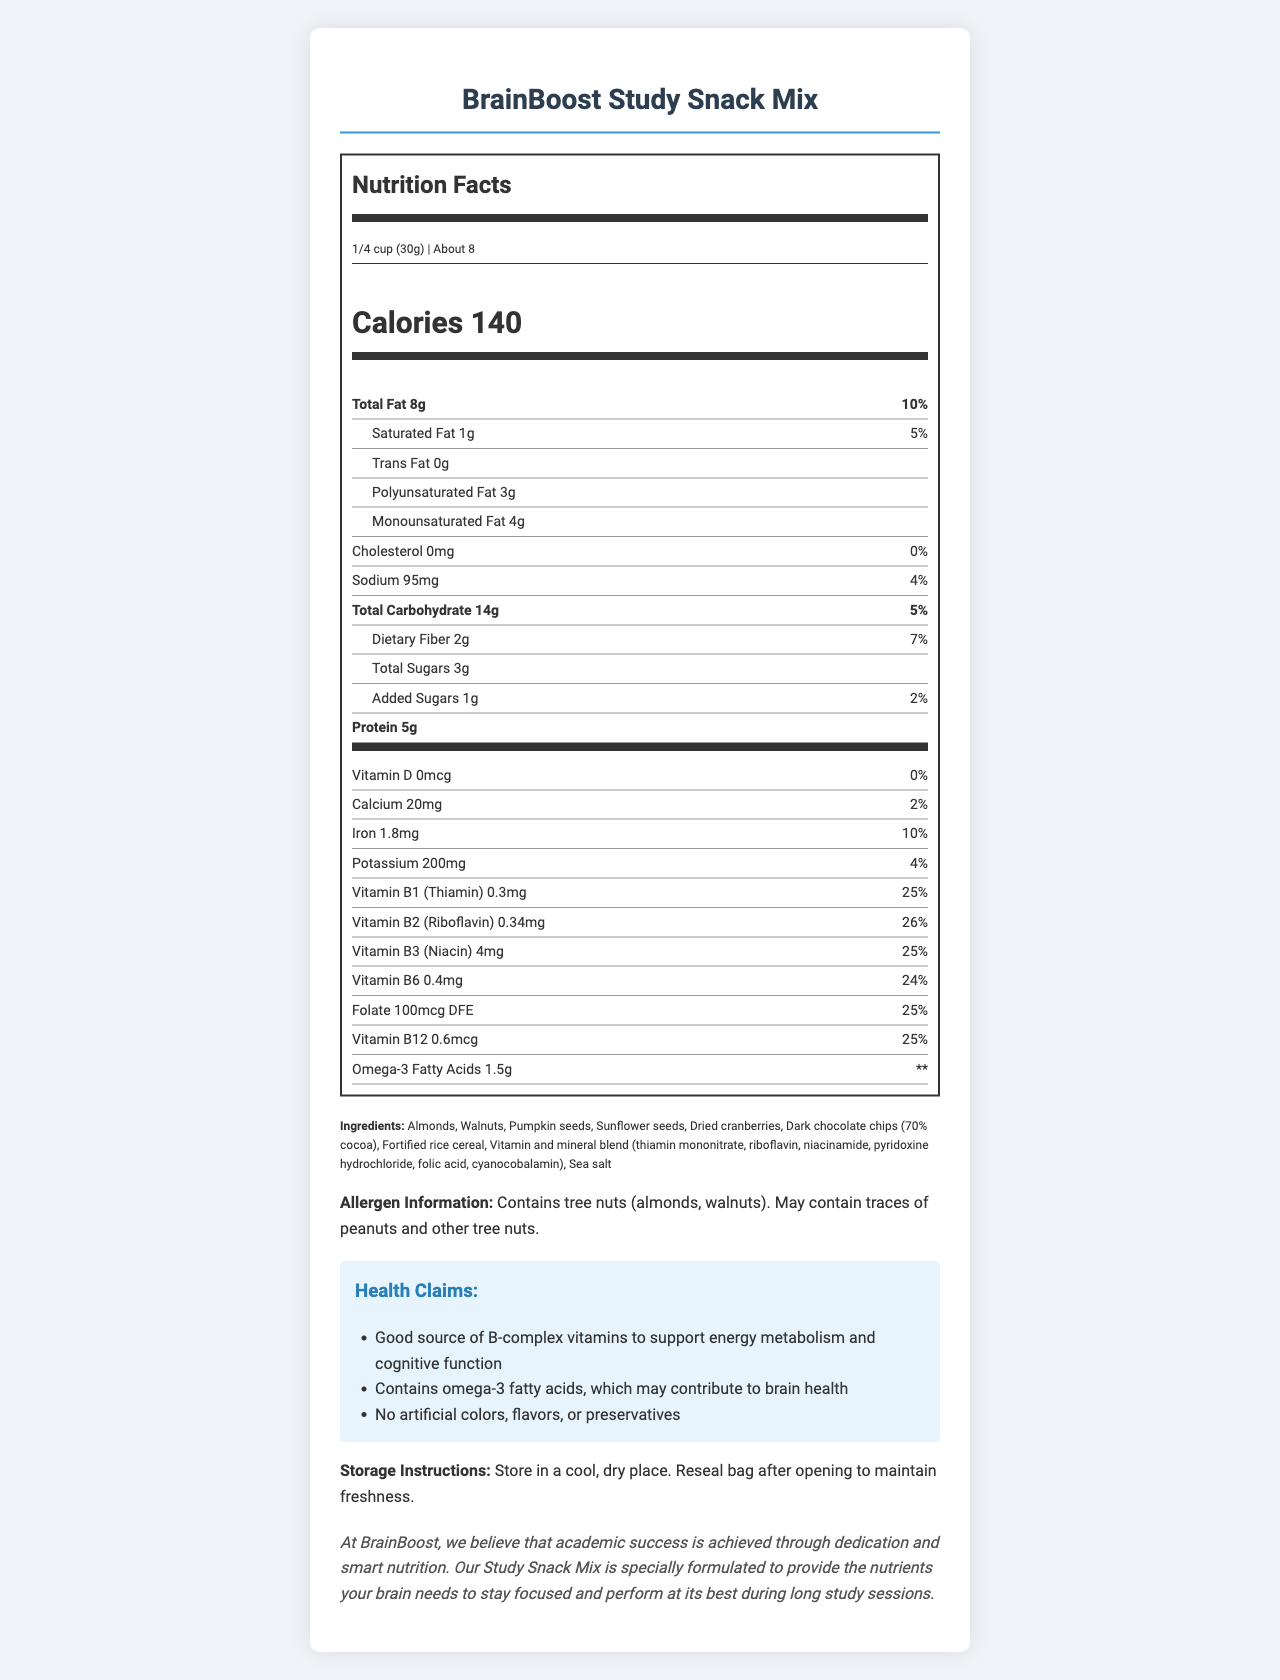what is the serving size of the BrainBoost Study Snack Mix? The document states the serving size as "1/4 cup (30g)".
Answer: 1/4 cup (30g) how many calories are there per serving? The document lists the calorie content as "Calories 140".
Answer: 140 which vitamin has the highest daily value percentage? The daily value percentages for vitamins are listed under the vitamins section, with Vitamin B2 (Riboflavin) having the highest percentage at 26%.
Answer: Vitamin B2 (Riboflavin) how much protein is in one serving? The document specifies that the amount of protein per serving is "5g".
Answer: 5g what is the percentage daily value for total fat? The document shows the percentage daily value for total fat as 10%.
Answer: 10% how many grams of omega-3 fatty acids are in a serving? The document lists "Omega-3 Fatty Acids 1.5g".
Answer: 1.5g how should the BrainBoost Study Snack Mix be stored? The storage instructions are provided in the document, instructing to store in a cool, dry place, and to reseal the bag after opening to maintain freshness.
Answer: In a cool, dry place. Reseal bag after opening to maintain freshness. how many servings are there per container? The document mentions that there are "About 8" servings per container.
Answer: About 8 what are the main ingredients in the study snack mix? A. Almonds, Walnuts, Dried cranberries, Fortified rice cereal B. Almonds, Walnuts, Raisins, Fortified rice cereal C. Almonds, Walnuts, Dried cranberries, Oats The ingredients section lists "Almonds, Walnuts, Pumpkin seeds, Sunflower seeds, Dried cranberries, Dark chocolate chips (70% cocoa), Fortified rice cereal, Vitamin and mineral blend, Sea salt", and option A contains the correct details.
Answer: A which nutrient does not contribute to the daily value? A. Omega-3 Fatty Acids B. Vitamin D C. Calcium D. Total Sugars The daily value for Omega-3 fatty acids is denoted by "**", indicating it does not contribute to the daily value.
Answer: A does the snack mix contain any tree nuts? The allergen information section states "Contains tree nuts (almonds, walnuts)."
Answer: Yes summarize the main idea of the document The document gives detailed nutritional information and emphasizes the health benefits and cognitive support properties of the snack mix. It highlights key nutrients and their advantages, lists ingredients, and gives allergen and storage information.
Answer: The BrainBoost Study Snack Mix is a vitamin-fortified snack designed to support energy metabolism and cognitive function for academic success. Each serving provides a good source of B-complex vitamins and omega-3 fatty acids, important for brain health. It contains various seeds, nuts, dried cranberries, dark chocolate chips, and fortified rice cereal, with additional vitamins and minerals. The snack mix is free from artificial colors, flavors, or preservatives, and contains specific storage instructions to maintain freshness. how many grams of polyunsaturated fat are in one serving? The document lists "Polyunsaturated Fat 3g".
Answer: 3g is there any added sugar in the BrainBoost Study Snack Mix? The document specifies "Added Sugars 1g".
Answer: Yes what are the health claims associated with the snack mix? The health claims section lists these three points.
Answer: 1. Good source of B-complex vitamins to support energy metabolism and cognitive function 2. Contains omega-3 fatty acids, which may contribute to brain health 3. No artificial colors, flavors, or preservatives what is the total carbohydrate content per serving? The document states that "Total Carbohydrate" per serving is "14g".
Answer: 14g what is the daily value percentage for vitamin D in the snack mix? The document lists the daily value percentage for vitamin D as "0%".
Answer: 0% how much folate does one serving provide? The document specifies "Folate 100mcg DFE".
Answer: 100mcg DFE what is the purpose of including omega-3 fatty acids in the snack mix? The health claims section mentions that omega-3 fatty acids may contribute to brain health.
Answer: To contribute to brain health Are there any artificial colors, flavors, or preservatives in this product? The health claims section states that the snack mix contains no artificial colors, flavors, or preservatives.
Answer: No how many grams of total sugars are in one serving? The document lists "Total Sugars 3g".
Answer: 3g what is the amount of cholesterol in one serving? The document specifies "Cholesterol 0mg".
Answer: 0mg which vitamin in the snack mix is also known as niacin? The vitamins section includes "Vitamin B3 (Niacin) 4mg".
Answer: Vitamin B3 what's the total amount of all sugars (natural and added) per serving? The total sugars section lists "Total Sugars 3g" and "Added Sugars 1g", so the total is 4g.
Answer: 4g which of these ingredients is not listed in the snack mix? A. Pumpkin seeds B. Raisins C. Sunflower seeds The ingredients section does not list raisins among the ingredients.
Answer: B where is this product manufactured? The provided document does not give details on the manufacturing location.
Answer: Not enough information 